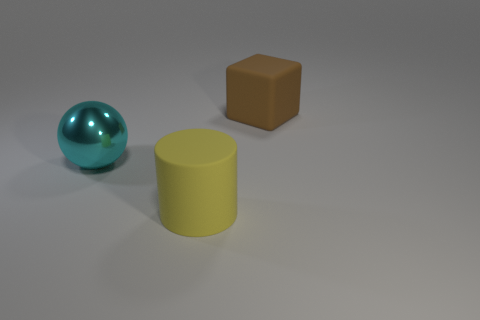There is a object that is right of the shiny sphere and in front of the large brown thing; how big is it?
Make the answer very short. Large. How many balls are either large yellow things or large shiny things?
Your answer should be very brief. 1. There is a block that is the same size as the cyan thing; what color is it?
Give a very brief answer. Brown. Is there any other thing that has the same shape as the big brown thing?
Your answer should be very brief. No. How many things are either tiny green cylinders or things on the left side of the big brown object?
Provide a short and direct response. 2. Is the number of large cyan metallic balls that are on the right side of the big cyan shiny ball less than the number of gray rubber things?
Give a very brief answer. No. What is the size of the object left of the large rubber thing that is in front of the rubber thing that is behind the cyan ball?
Keep it short and to the point. Large. The big object that is both right of the big ball and left of the large brown thing is what color?
Keep it short and to the point. Yellow. What number of small purple shiny objects are there?
Offer a very short reply. 0. Is there anything else that is the same size as the cyan thing?
Ensure brevity in your answer.  Yes. 